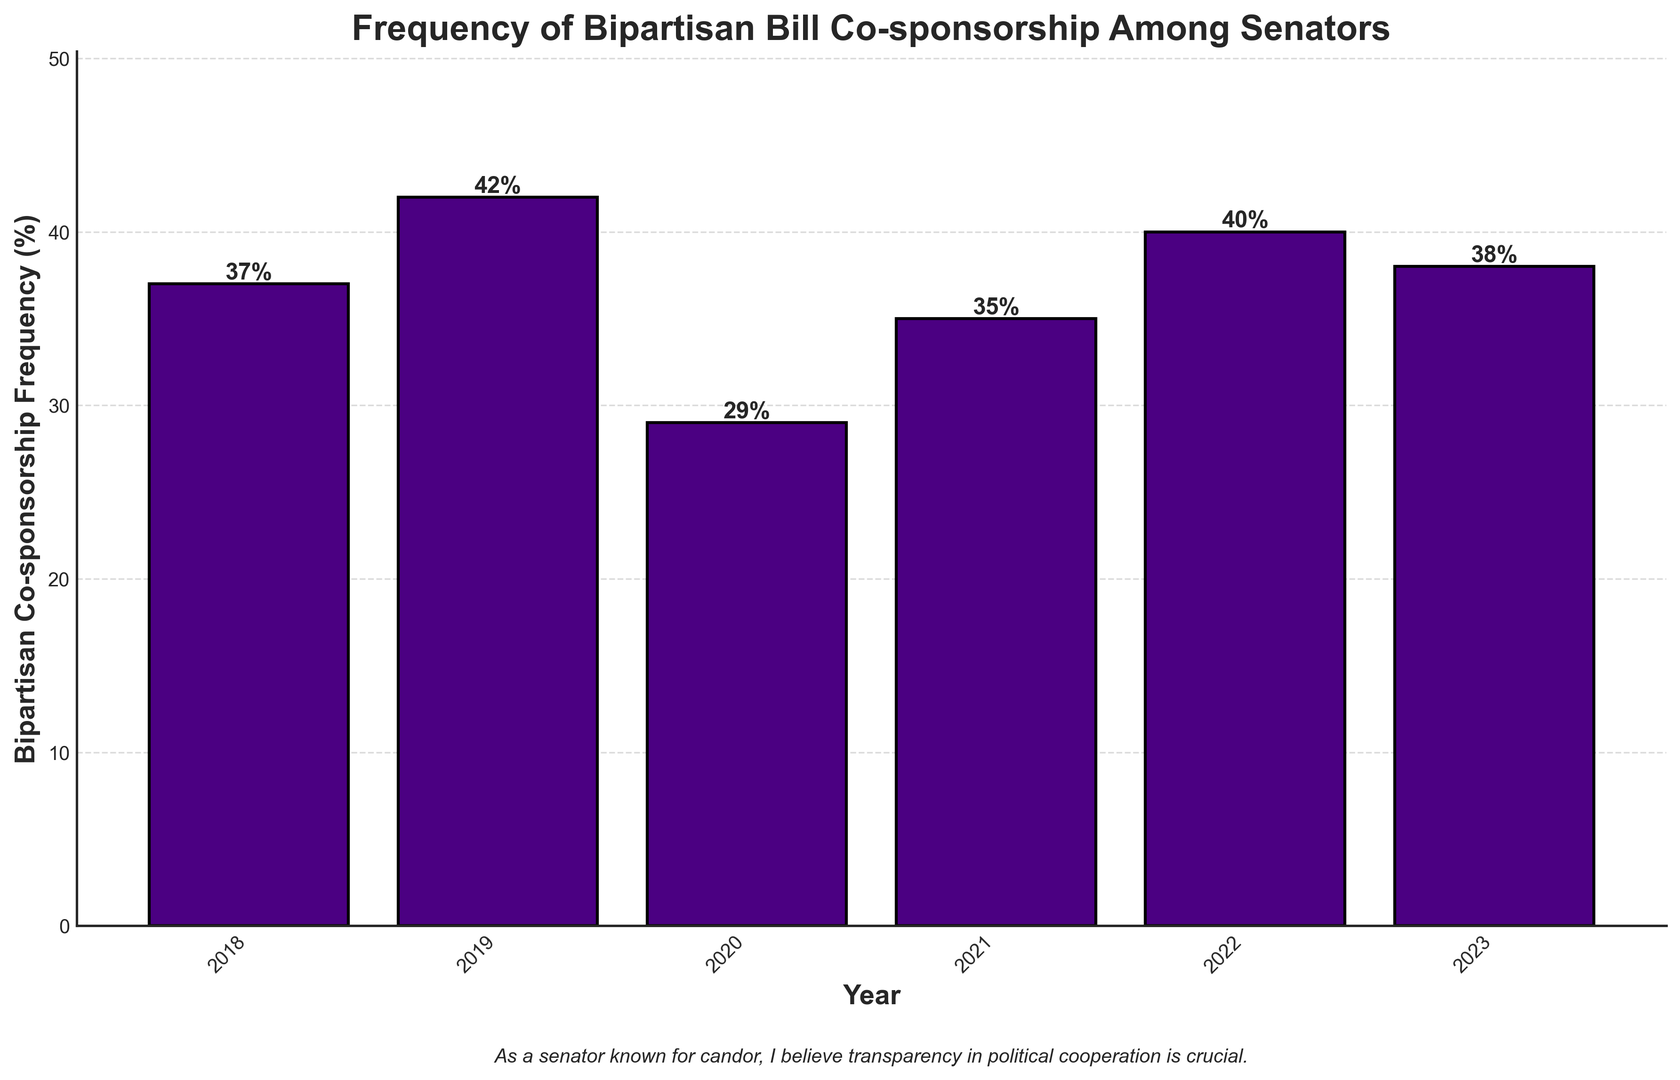Which year had the highest frequency of bipartisan bill co-sponsorship? Look at the heights of the bars in the bar chart and identify the tallest bar. The year corresponding to this bar is 2019 with a frequency of 42%.
Answer: 2019 Which year had the lowest frequency of bipartisan bill co-sponsorship? Look at the heights of the bars in the bar chart and identify the shortest bar. The year corresponding to this bar is 2020 with a frequency of 29%.
Answer: 2020 What is the average frequency of bipartisan bill co-sponsorship over the years presented? To find the average, sum the frequencies (37 + 42 + 29 + 35 + 40 + 38) and divide by the number of years (6). The sum is 221, so the average is 221/6 = ~36.83.
Answer: ~36.83 How much did the frequency of bipartisan bill co-sponsorship increase from 2020 to 2021? Subtract the frequency in 2020 (29%) from the frequency in 2021 (35%). The increase is 35% - 29% = 6%.
Answer: 6% Between which two consecutive years did the frequency of bipartisan bill co-sponsorship experience the largest increase? Compare the differences between each consecutive year's frequencies: 2019-2018 = 42% - 37% = 5%; 2020-2019 = 29% - 42% = -13%; 2021-2020 = 35% - 29% = 6%; 2022-2021 = 40% - 35% = 5%; 2023-2022 = 38% - 40% = -2%. The largest increase is between 2020 and 2021, which is 6%.
Answer: 2020 to 2021 What is the cumulative frequency of bipartisan bill co-sponsorship from 2018 to 2020? Sum the frequencies for the years 2018 (37%), 2019 (42%), and 2020 (29%) which gives 37% + 42% + 29% = 108%.
Answer: 108% Is the frequency in 2023 higher or lower than the frequency in 2019? Compare the heights of the bars for 2023 (38%) and 2019 (42%). The frequency in 2023 is lower than in 2019.
Answer: Lower What is the median frequency of bipartisan bill co-sponsorship for the given years? List the frequencies in ascending order: 29%, 35%, 37%, 38%, 40%, 42%. The median is the average of the third and fourth values, (37% + 38%)/2 = 37.5%.
Answer: 37.5% Which year had a frequency of bipartisan bill co-sponsorship exactly 2% higher than 2018? Add 2% to the 2018 frequency (37% + 2% = 39%) and identify the closest year in the data. The closest match is 2022 with 40%.
Answer: 2022 